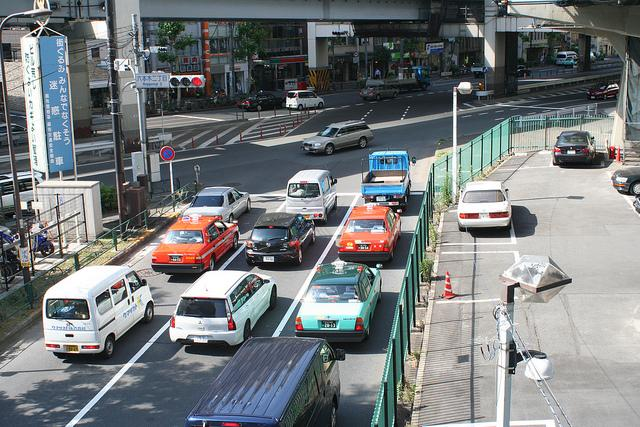What make is the white vehicle to the left of the green white cab?

Choices:
A) mitsubishi
B) lexus
C) audi
D) ford mitsubishi 